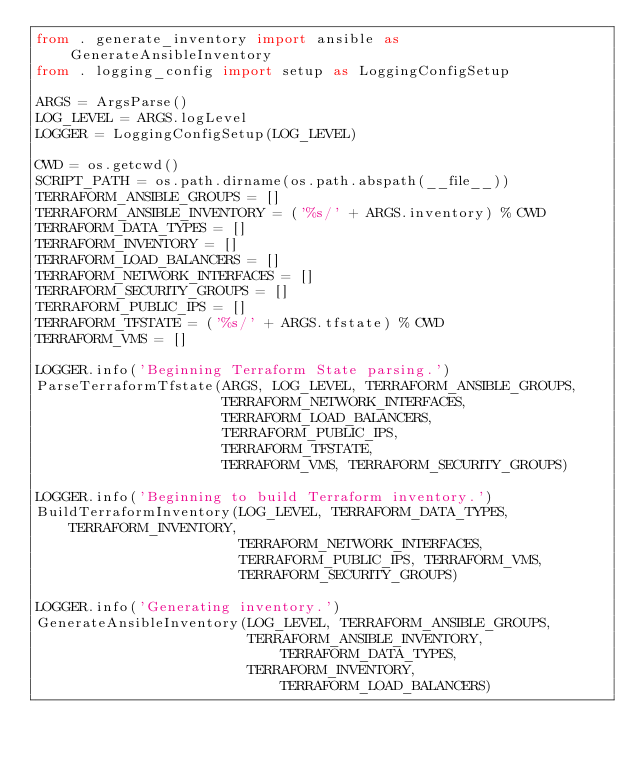<code> <loc_0><loc_0><loc_500><loc_500><_Python_>from . generate_inventory import ansible as GenerateAnsibleInventory
from . logging_config import setup as LoggingConfigSetup

ARGS = ArgsParse()
LOG_LEVEL = ARGS.logLevel
LOGGER = LoggingConfigSetup(LOG_LEVEL)

CWD = os.getcwd()
SCRIPT_PATH = os.path.dirname(os.path.abspath(__file__))
TERRAFORM_ANSIBLE_GROUPS = []
TERRAFORM_ANSIBLE_INVENTORY = ('%s/' + ARGS.inventory) % CWD
TERRAFORM_DATA_TYPES = []
TERRAFORM_INVENTORY = []
TERRAFORM_LOAD_BALANCERS = []
TERRAFORM_NETWORK_INTERFACES = []
TERRAFORM_SECURITY_GROUPS = []
TERRAFORM_PUBLIC_IPS = []
TERRAFORM_TFSTATE = ('%s/' + ARGS.tfstate) % CWD
TERRAFORM_VMS = []

LOGGER.info('Beginning Terraform State parsing.')
ParseTerraformTfstate(ARGS, LOG_LEVEL, TERRAFORM_ANSIBLE_GROUPS,
                      TERRAFORM_NETWORK_INTERFACES,
                      TERRAFORM_LOAD_BALANCERS,
                      TERRAFORM_PUBLIC_IPS,
                      TERRAFORM_TFSTATE,
                      TERRAFORM_VMS, TERRAFORM_SECURITY_GROUPS)

LOGGER.info('Beginning to build Terraform inventory.')
BuildTerraformInventory(LOG_LEVEL, TERRAFORM_DATA_TYPES, TERRAFORM_INVENTORY,
                        TERRAFORM_NETWORK_INTERFACES,
                        TERRAFORM_PUBLIC_IPS, TERRAFORM_VMS,
                        TERRAFORM_SECURITY_GROUPS)

LOGGER.info('Generating inventory.')
GenerateAnsibleInventory(LOG_LEVEL, TERRAFORM_ANSIBLE_GROUPS,
                         TERRAFORM_ANSIBLE_INVENTORY, TERRAFORM_DATA_TYPES,
                         TERRAFORM_INVENTORY, TERRAFORM_LOAD_BALANCERS)
</code> 